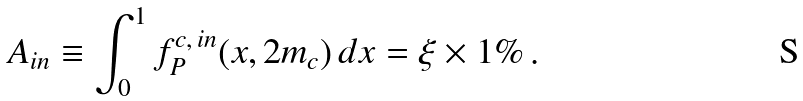<formula> <loc_0><loc_0><loc_500><loc_500>A _ { i n } \equiv \int _ { 0 } ^ { 1 } f _ { P } ^ { c , \, i n } ( x , 2 m _ { c } ) \, d x = \xi \times 1 \% \, .</formula> 